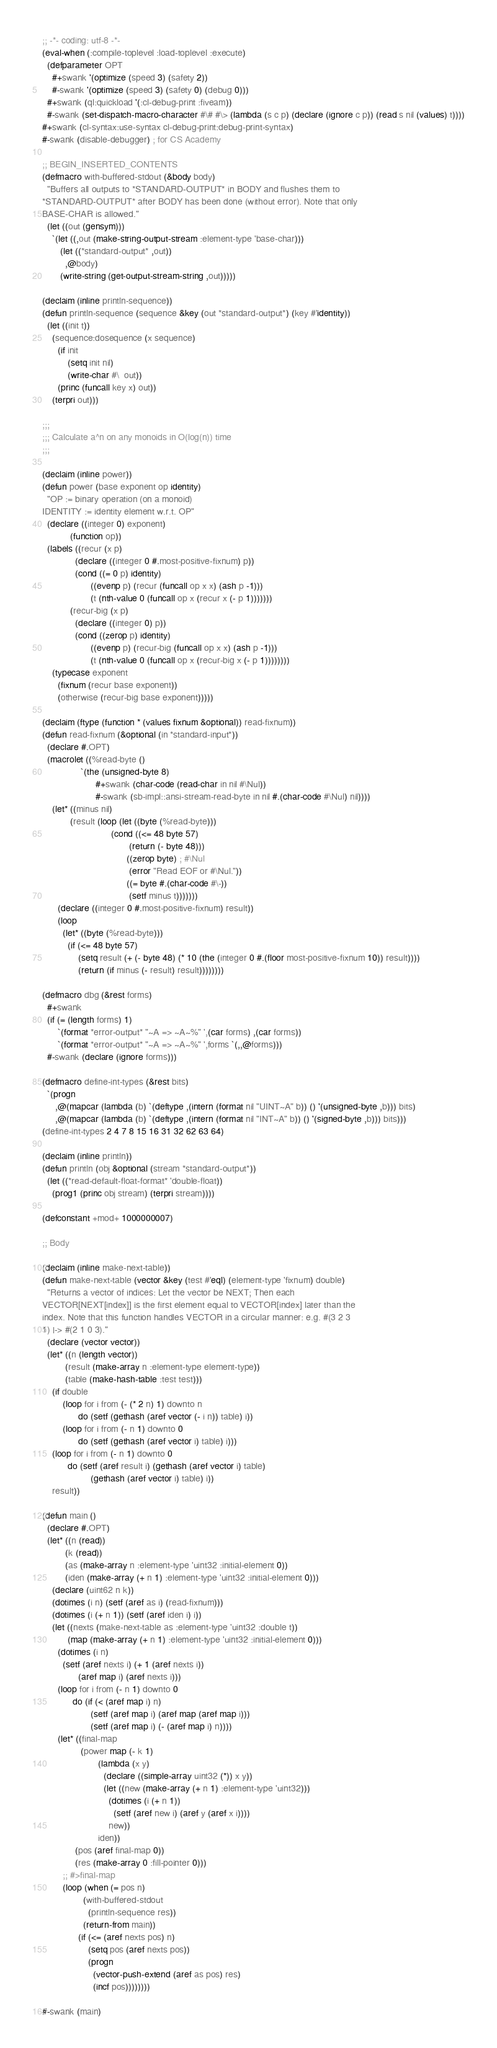Convert code to text. <code><loc_0><loc_0><loc_500><loc_500><_Lisp_>;; -*- coding: utf-8 -*-
(eval-when (:compile-toplevel :load-toplevel :execute)
  (defparameter OPT
    #+swank '(optimize (speed 3) (safety 2))
    #-swank '(optimize (speed 3) (safety 0) (debug 0)))
  #+swank (ql:quickload '(:cl-debug-print :fiveam))
  #-swank (set-dispatch-macro-character #\# #\> (lambda (s c p) (declare (ignore c p)) (read s nil (values) t))))
#+swank (cl-syntax:use-syntax cl-debug-print:debug-print-syntax)
#-swank (disable-debugger) ; for CS Academy

;; BEGIN_INSERTED_CONTENTS
(defmacro with-buffered-stdout (&body body)
  "Buffers all outputs to *STANDARD-OUTPUT* in BODY and flushes them to
*STANDARD-OUTPUT* after BODY has been done (without error). Note that only
BASE-CHAR is allowed."
  (let ((out (gensym)))
    `(let ((,out (make-string-output-stream :element-type 'base-char)))
       (let ((*standard-output* ,out))
         ,@body)
       (write-string (get-output-stream-string ,out)))))

(declaim (inline println-sequence))
(defun println-sequence (sequence &key (out *standard-output*) (key #'identity))
  (let ((init t))
    (sequence:dosequence (x sequence)
      (if init
          (setq init nil)
          (write-char #\  out))
      (princ (funcall key x) out))
    (terpri out)))

;;;
;;; Calculate a^n on any monoids in O(log(n)) time
;;;

(declaim (inline power))
(defun power (base exponent op identity)
  "OP := binary operation (on a monoid)
IDENTITY := identity element w.r.t. OP"
  (declare ((integer 0) exponent)
           (function op))
  (labels ((recur (x p)
             (declare ((integer 0 #.most-positive-fixnum) p))
             (cond ((= 0 p) identity)
                   ((evenp p) (recur (funcall op x x) (ash p -1)))
                   (t (nth-value 0 (funcall op x (recur x (- p 1)))))))
           (recur-big (x p)
             (declare ((integer 0) p))
             (cond ((zerop p) identity)
                   ((evenp p) (recur-big (funcall op x x) (ash p -1)))
                   (t (nth-value 0 (funcall op x (recur-big x (- p 1))))))))
    (typecase exponent
      (fixnum (recur base exponent))
      (otherwise (recur-big base exponent)))))

(declaim (ftype (function * (values fixnum &optional)) read-fixnum))
(defun read-fixnum (&optional (in *standard-input*))
  (declare #.OPT)
  (macrolet ((%read-byte ()
               `(the (unsigned-byte 8)
                     #+swank (char-code (read-char in nil #\Nul))
                     #-swank (sb-impl::ansi-stream-read-byte in nil #.(char-code #\Nul) nil))))
    (let* ((minus nil)
           (result (loop (let ((byte (%read-byte)))
                           (cond ((<= 48 byte 57)
                                  (return (- byte 48)))
                                 ((zerop byte) ; #\Nul
                                  (error "Read EOF or #\Nul."))
                                 ((= byte #.(char-code #\-))
                                  (setf minus t)))))))
      (declare ((integer 0 #.most-positive-fixnum) result))
      (loop
        (let* ((byte (%read-byte)))
          (if (<= 48 byte 57)
              (setq result (+ (- byte 48) (* 10 (the (integer 0 #.(floor most-positive-fixnum 10)) result))))
              (return (if minus (- result) result))))))))

(defmacro dbg (&rest forms)
  #+swank
  (if (= (length forms) 1)
      `(format *error-output* "~A => ~A~%" ',(car forms) ,(car forms))
      `(format *error-output* "~A => ~A~%" ',forms `(,,@forms)))
  #-swank (declare (ignore forms)))

(defmacro define-int-types (&rest bits)
  `(progn
     ,@(mapcar (lambda (b) `(deftype ,(intern (format nil "UINT~A" b)) () '(unsigned-byte ,b))) bits)
     ,@(mapcar (lambda (b) `(deftype ,(intern (format nil "INT~A" b)) () '(signed-byte ,b))) bits)))
(define-int-types 2 4 7 8 15 16 31 32 62 63 64)

(declaim (inline println))
(defun println (obj &optional (stream *standard-output*))
  (let ((*read-default-float-format* 'double-float))
    (prog1 (princ obj stream) (terpri stream))))

(defconstant +mod+ 1000000007)

;; Body

(declaim (inline make-next-table))
(defun make-next-table (vector &key (test #'eql) (element-type 'fixnum) double)
  "Returns a vector of indices: Let the vector be NEXT; Then each
VECTOR[NEXT[index]] is the first element equal to VECTOR[index] later than the
index. Note that this function handles VECTOR in a circular manner: e.g. #(3 2 3
1) |-> #(2 1 0 3)."
  (declare (vector vector))
  (let* ((n (length vector))
         (result (make-array n :element-type element-type))
         (table (make-hash-table :test test)))
    (if double
        (loop for i from (- (* 2 n) 1) downto n
              do (setf (gethash (aref vector (- i n)) table) i))
        (loop for i from (- n 1) downto 0
              do (setf (gethash (aref vector i) table) i)))
    (loop for i from (- n 1) downto 0
          do (setf (aref result i) (gethash (aref vector i) table)
                   (gethash (aref vector i) table) i))
    result))

(defun main ()
  (declare #.OPT)
  (let* ((n (read))
         (k (read))
         (as (make-array n :element-type 'uint32 :initial-element 0))
         (iden (make-array (+ n 1) :element-type 'uint32 :initial-element 0)))
    (declare (uint62 n k))
    (dotimes (i n) (setf (aref as i) (read-fixnum)))
    (dotimes (i (+ n 1)) (setf (aref iden i) i))
    (let ((nexts (make-next-table as :element-type 'uint32 :double t))
          (map (make-array (+ n 1) :element-type 'uint32 :initial-element 0)))
      (dotimes (i n)
        (setf (aref nexts i) (+ 1 (aref nexts i))
              (aref map i) (aref nexts i)))
      (loop for i from (- n 1) downto 0
            do (if (< (aref map i) n)
                   (setf (aref map i) (aref map (aref map i)))
                   (setf (aref map i) (- (aref map i) n))))
      (let* ((final-map
               (power map (- k 1)
                      (lambda (x y)
                        (declare ((simple-array uint32 (*)) x y))
                        (let ((new (make-array (+ n 1) :element-type 'uint32)))
                          (dotimes (i (+ n 1))
                            (setf (aref new i) (aref y (aref x i))))
                          new))
                      iden))
             (pos (aref final-map 0))
             (res (make-array 0 :fill-pointer 0)))
        ;; #>final-map
        (loop (when (= pos n)
                (with-buffered-stdout
                  (println-sequence res))
                (return-from main))
              (if (<= (aref nexts pos) n)
                  (setq pos (aref nexts pos))
                  (progn
                    (vector-push-extend (aref as pos) res)
                    (incf pos))))))))

#-swank (main)
</code> 